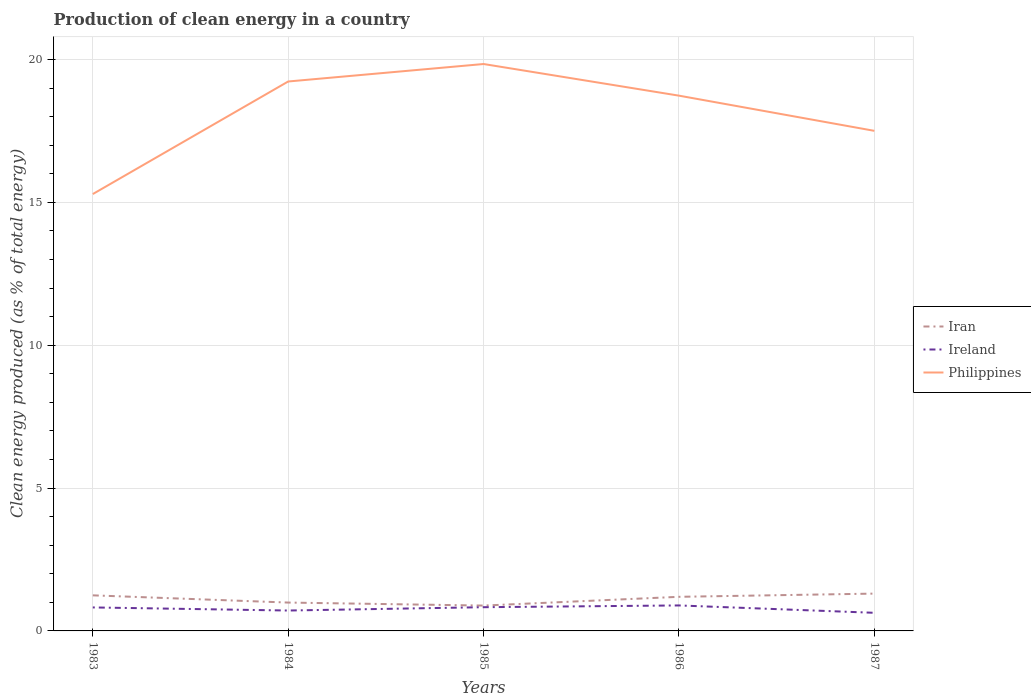Does the line corresponding to Philippines intersect with the line corresponding to Ireland?
Your response must be concise. No. Is the number of lines equal to the number of legend labels?
Provide a short and direct response. Yes. Across all years, what is the maximum percentage of clean energy produced in Ireland?
Provide a succinct answer. 0.63. What is the total percentage of clean energy produced in Philippines in the graph?
Provide a short and direct response. 1.11. What is the difference between the highest and the second highest percentage of clean energy produced in Iran?
Your answer should be very brief. 0.42. What is the difference between the highest and the lowest percentage of clean energy produced in Philippines?
Offer a very short reply. 3. Are the values on the major ticks of Y-axis written in scientific E-notation?
Ensure brevity in your answer.  No. Does the graph contain any zero values?
Your response must be concise. No. How are the legend labels stacked?
Make the answer very short. Vertical. What is the title of the graph?
Offer a very short reply. Production of clean energy in a country. Does "Congo (Democratic)" appear as one of the legend labels in the graph?
Offer a very short reply. No. What is the label or title of the Y-axis?
Ensure brevity in your answer.  Clean energy produced (as % of total energy). What is the Clean energy produced (as % of total energy) in Iran in 1983?
Offer a very short reply. 1.25. What is the Clean energy produced (as % of total energy) of Ireland in 1983?
Give a very brief answer. 0.82. What is the Clean energy produced (as % of total energy) of Philippines in 1983?
Offer a terse response. 15.29. What is the Clean energy produced (as % of total energy) in Iran in 1984?
Your answer should be compact. 0.99. What is the Clean energy produced (as % of total energy) in Ireland in 1984?
Offer a very short reply. 0.71. What is the Clean energy produced (as % of total energy) of Philippines in 1984?
Give a very brief answer. 19.23. What is the Clean energy produced (as % of total energy) in Iran in 1985?
Your answer should be compact. 0.89. What is the Clean energy produced (as % of total energy) of Ireland in 1985?
Offer a very short reply. 0.83. What is the Clean energy produced (as % of total energy) in Philippines in 1985?
Your answer should be very brief. 19.84. What is the Clean energy produced (as % of total energy) in Iran in 1986?
Keep it short and to the point. 1.19. What is the Clean energy produced (as % of total energy) in Ireland in 1986?
Offer a very short reply. 0.89. What is the Clean energy produced (as % of total energy) of Philippines in 1986?
Your response must be concise. 18.73. What is the Clean energy produced (as % of total energy) in Iran in 1987?
Give a very brief answer. 1.31. What is the Clean energy produced (as % of total energy) in Ireland in 1987?
Offer a terse response. 0.63. What is the Clean energy produced (as % of total energy) of Philippines in 1987?
Your response must be concise. 17.5. Across all years, what is the maximum Clean energy produced (as % of total energy) of Iran?
Give a very brief answer. 1.31. Across all years, what is the maximum Clean energy produced (as % of total energy) of Ireland?
Offer a very short reply. 0.89. Across all years, what is the maximum Clean energy produced (as % of total energy) in Philippines?
Keep it short and to the point. 19.84. Across all years, what is the minimum Clean energy produced (as % of total energy) in Iran?
Offer a terse response. 0.89. Across all years, what is the minimum Clean energy produced (as % of total energy) in Ireland?
Make the answer very short. 0.63. Across all years, what is the minimum Clean energy produced (as % of total energy) of Philippines?
Make the answer very short. 15.29. What is the total Clean energy produced (as % of total energy) of Iran in the graph?
Make the answer very short. 5.63. What is the total Clean energy produced (as % of total energy) in Ireland in the graph?
Give a very brief answer. 3.89. What is the total Clean energy produced (as % of total energy) in Philippines in the graph?
Your answer should be compact. 90.6. What is the difference between the Clean energy produced (as % of total energy) in Iran in 1983 and that in 1984?
Make the answer very short. 0.25. What is the difference between the Clean energy produced (as % of total energy) in Ireland in 1983 and that in 1984?
Give a very brief answer. 0.11. What is the difference between the Clean energy produced (as % of total energy) in Philippines in 1983 and that in 1984?
Make the answer very short. -3.94. What is the difference between the Clean energy produced (as % of total energy) in Iran in 1983 and that in 1985?
Offer a very short reply. 0.36. What is the difference between the Clean energy produced (as % of total energy) of Ireland in 1983 and that in 1985?
Provide a short and direct response. -0.01. What is the difference between the Clean energy produced (as % of total energy) of Philippines in 1983 and that in 1985?
Offer a very short reply. -4.55. What is the difference between the Clean energy produced (as % of total energy) in Iran in 1983 and that in 1986?
Your answer should be compact. 0.05. What is the difference between the Clean energy produced (as % of total energy) in Ireland in 1983 and that in 1986?
Provide a succinct answer. -0.07. What is the difference between the Clean energy produced (as % of total energy) in Philippines in 1983 and that in 1986?
Offer a very short reply. -3.44. What is the difference between the Clean energy produced (as % of total energy) in Iran in 1983 and that in 1987?
Keep it short and to the point. -0.06. What is the difference between the Clean energy produced (as % of total energy) in Ireland in 1983 and that in 1987?
Offer a terse response. 0.19. What is the difference between the Clean energy produced (as % of total energy) of Philippines in 1983 and that in 1987?
Provide a short and direct response. -2.21. What is the difference between the Clean energy produced (as % of total energy) in Iran in 1984 and that in 1985?
Offer a terse response. 0.11. What is the difference between the Clean energy produced (as % of total energy) in Ireland in 1984 and that in 1985?
Keep it short and to the point. -0.12. What is the difference between the Clean energy produced (as % of total energy) of Philippines in 1984 and that in 1985?
Make the answer very short. -0.61. What is the difference between the Clean energy produced (as % of total energy) in Iran in 1984 and that in 1986?
Your response must be concise. -0.2. What is the difference between the Clean energy produced (as % of total energy) in Ireland in 1984 and that in 1986?
Provide a succinct answer. -0.18. What is the difference between the Clean energy produced (as % of total energy) of Philippines in 1984 and that in 1986?
Offer a very short reply. 0.5. What is the difference between the Clean energy produced (as % of total energy) of Iran in 1984 and that in 1987?
Give a very brief answer. -0.31. What is the difference between the Clean energy produced (as % of total energy) of Ireland in 1984 and that in 1987?
Ensure brevity in your answer.  0.08. What is the difference between the Clean energy produced (as % of total energy) of Philippines in 1984 and that in 1987?
Provide a succinct answer. 1.73. What is the difference between the Clean energy produced (as % of total energy) of Iran in 1985 and that in 1986?
Ensure brevity in your answer.  -0.31. What is the difference between the Clean energy produced (as % of total energy) in Ireland in 1985 and that in 1986?
Your answer should be compact. -0.06. What is the difference between the Clean energy produced (as % of total energy) in Philippines in 1985 and that in 1986?
Offer a very short reply. 1.11. What is the difference between the Clean energy produced (as % of total energy) in Iran in 1985 and that in 1987?
Your response must be concise. -0.42. What is the difference between the Clean energy produced (as % of total energy) in Ireland in 1985 and that in 1987?
Keep it short and to the point. 0.2. What is the difference between the Clean energy produced (as % of total energy) of Philippines in 1985 and that in 1987?
Provide a short and direct response. 2.34. What is the difference between the Clean energy produced (as % of total energy) of Iran in 1986 and that in 1987?
Your answer should be very brief. -0.11. What is the difference between the Clean energy produced (as % of total energy) in Ireland in 1986 and that in 1987?
Your response must be concise. 0.26. What is the difference between the Clean energy produced (as % of total energy) of Philippines in 1986 and that in 1987?
Ensure brevity in your answer.  1.23. What is the difference between the Clean energy produced (as % of total energy) of Iran in 1983 and the Clean energy produced (as % of total energy) of Ireland in 1984?
Your response must be concise. 0.53. What is the difference between the Clean energy produced (as % of total energy) in Iran in 1983 and the Clean energy produced (as % of total energy) in Philippines in 1984?
Your answer should be compact. -17.99. What is the difference between the Clean energy produced (as % of total energy) of Ireland in 1983 and the Clean energy produced (as % of total energy) of Philippines in 1984?
Keep it short and to the point. -18.41. What is the difference between the Clean energy produced (as % of total energy) of Iran in 1983 and the Clean energy produced (as % of total energy) of Ireland in 1985?
Offer a very short reply. 0.42. What is the difference between the Clean energy produced (as % of total energy) in Iran in 1983 and the Clean energy produced (as % of total energy) in Philippines in 1985?
Provide a succinct answer. -18.6. What is the difference between the Clean energy produced (as % of total energy) of Ireland in 1983 and the Clean energy produced (as % of total energy) of Philippines in 1985?
Offer a terse response. -19.02. What is the difference between the Clean energy produced (as % of total energy) of Iran in 1983 and the Clean energy produced (as % of total energy) of Ireland in 1986?
Give a very brief answer. 0.35. What is the difference between the Clean energy produced (as % of total energy) in Iran in 1983 and the Clean energy produced (as % of total energy) in Philippines in 1986?
Keep it short and to the point. -17.49. What is the difference between the Clean energy produced (as % of total energy) of Ireland in 1983 and the Clean energy produced (as % of total energy) of Philippines in 1986?
Offer a very short reply. -17.91. What is the difference between the Clean energy produced (as % of total energy) of Iran in 1983 and the Clean energy produced (as % of total energy) of Ireland in 1987?
Offer a terse response. 0.61. What is the difference between the Clean energy produced (as % of total energy) in Iran in 1983 and the Clean energy produced (as % of total energy) in Philippines in 1987?
Ensure brevity in your answer.  -16.26. What is the difference between the Clean energy produced (as % of total energy) in Ireland in 1983 and the Clean energy produced (as % of total energy) in Philippines in 1987?
Give a very brief answer. -16.68. What is the difference between the Clean energy produced (as % of total energy) of Iran in 1984 and the Clean energy produced (as % of total energy) of Ireland in 1985?
Offer a terse response. 0.16. What is the difference between the Clean energy produced (as % of total energy) in Iran in 1984 and the Clean energy produced (as % of total energy) in Philippines in 1985?
Give a very brief answer. -18.85. What is the difference between the Clean energy produced (as % of total energy) in Ireland in 1984 and the Clean energy produced (as % of total energy) in Philippines in 1985?
Ensure brevity in your answer.  -19.13. What is the difference between the Clean energy produced (as % of total energy) of Iran in 1984 and the Clean energy produced (as % of total energy) of Ireland in 1986?
Offer a very short reply. 0.1. What is the difference between the Clean energy produced (as % of total energy) of Iran in 1984 and the Clean energy produced (as % of total energy) of Philippines in 1986?
Your response must be concise. -17.74. What is the difference between the Clean energy produced (as % of total energy) of Ireland in 1984 and the Clean energy produced (as % of total energy) of Philippines in 1986?
Provide a succinct answer. -18.02. What is the difference between the Clean energy produced (as % of total energy) of Iran in 1984 and the Clean energy produced (as % of total energy) of Ireland in 1987?
Give a very brief answer. 0.36. What is the difference between the Clean energy produced (as % of total energy) in Iran in 1984 and the Clean energy produced (as % of total energy) in Philippines in 1987?
Offer a terse response. -16.51. What is the difference between the Clean energy produced (as % of total energy) in Ireland in 1984 and the Clean energy produced (as % of total energy) in Philippines in 1987?
Give a very brief answer. -16.79. What is the difference between the Clean energy produced (as % of total energy) of Iran in 1985 and the Clean energy produced (as % of total energy) of Ireland in 1986?
Keep it short and to the point. -0. What is the difference between the Clean energy produced (as % of total energy) in Iran in 1985 and the Clean energy produced (as % of total energy) in Philippines in 1986?
Give a very brief answer. -17.85. What is the difference between the Clean energy produced (as % of total energy) of Ireland in 1985 and the Clean energy produced (as % of total energy) of Philippines in 1986?
Keep it short and to the point. -17.9. What is the difference between the Clean energy produced (as % of total energy) in Iran in 1985 and the Clean energy produced (as % of total energy) in Ireland in 1987?
Your answer should be very brief. 0.25. What is the difference between the Clean energy produced (as % of total energy) of Iran in 1985 and the Clean energy produced (as % of total energy) of Philippines in 1987?
Provide a succinct answer. -16.62. What is the difference between the Clean energy produced (as % of total energy) of Ireland in 1985 and the Clean energy produced (as % of total energy) of Philippines in 1987?
Keep it short and to the point. -16.67. What is the difference between the Clean energy produced (as % of total energy) of Iran in 1986 and the Clean energy produced (as % of total energy) of Ireland in 1987?
Offer a terse response. 0.56. What is the difference between the Clean energy produced (as % of total energy) of Iran in 1986 and the Clean energy produced (as % of total energy) of Philippines in 1987?
Your answer should be compact. -16.31. What is the difference between the Clean energy produced (as % of total energy) in Ireland in 1986 and the Clean energy produced (as % of total energy) in Philippines in 1987?
Offer a very short reply. -16.61. What is the average Clean energy produced (as % of total energy) of Iran per year?
Your answer should be very brief. 1.13. What is the average Clean energy produced (as % of total energy) of Ireland per year?
Ensure brevity in your answer.  0.78. What is the average Clean energy produced (as % of total energy) in Philippines per year?
Your answer should be compact. 18.12. In the year 1983, what is the difference between the Clean energy produced (as % of total energy) of Iran and Clean energy produced (as % of total energy) of Ireland?
Ensure brevity in your answer.  0.42. In the year 1983, what is the difference between the Clean energy produced (as % of total energy) of Iran and Clean energy produced (as % of total energy) of Philippines?
Provide a short and direct response. -14.05. In the year 1983, what is the difference between the Clean energy produced (as % of total energy) in Ireland and Clean energy produced (as % of total energy) in Philippines?
Offer a terse response. -14.47. In the year 1984, what is the difference between the Clean energy produced (as % of total energy) in Iran and Clean energy produced (as % of total energy) in Ireland?
Provide a short and direct response. 0.28. In the year 1984, what is the difference between the Clean energy produced (as % of total energy) of Iran and Clean energy produced (as % of total energy) of Philippines?
Ensure brevity in your answer.  -18.24. In the year 1984, what is the difference between the Clean energy produced (as % of total energy) of Ireland and Clean energy produced (as % of total energy) of Philippines?
Make the answer very short. -18.52. In the year 1985, what is the difference between the Clean energy produced (as % of total energy) in Iran and Clean energy produced (as % of total energy) in Ireland?
Make the answer very short. 0.06. In the year 1985, what is the difference between the Clean energy produced (as % of total energy) in Iran and Clean energy produced (as % of total energy) in Philippines?
Ensure brevity in your answer.  -18.96. In the year 1985, what is the difference between the Clean energy produced (as % of total energy) in Ireland and Clean energy produced (as % of total energy) in Philippines?
Offer a very short reply. -19.01. In the year 1986, what is the difference between the Clean energy produced (as % of total energy) in Iran and Clean energy produced (as % of total energy) in Ireland?
Offer a terse response. 0.3. In the year 1986, what is the difference between the Clean energy produced (as % of total energy) of Iran and Clean energy produced (as % of total energy) of Philippines?
Offer a very short reply. -17.54. In the year 1986, what is the difference between the Clean energy produced (as % of total energy) in Ireland and Clean energy produced (as % of total energy) in Philippines?
Offer a terse response. -17.84. In the year 1987, what is the difference between the Clean energy produced (as % of total energy) of Iran and Clean energy produced (as % of total energy) of Ireland?
Give a very brief answer. 0.67. In the year 1987, what is the difference between the Clean energy produced (as % of total energy) of Iran and Clean energy produced (as % of total energy) of Philippines?
Your answer should be compact. -16.2. In the year 1987, what is the difference between the Clean energy produced (as % of total energy) in Ireland and Clean energy produced (as % of total energy) in Philippines?
Your response must be concise. -16.87. What is the ratio of the Clean energy produced (as % of total energy) in Iran in 1983 to that in 1984?
Give a very brief answer. 1.25. What is the ratio of the Clean energy produced (as % of total energy) of Ireland in 1983 to that in 1984?
Make the answer very short. 1.15. What is the ratio of the Clean energy produced (as % of total energy) in Philippines in 1983 to that in 1984?
Ensure brevity in your answer.  0.8. What is the ratio of the Clean energy produced (as % of total energy) in Iran in 1983 to that in 1985?
Ensure brevity in your answer.  1.4. What is the ratio of the Clean energy produced (as % of total energy) of Ireland in 1983 to that in 1985?
Give a very brief answer. 0.99. What is the ratio of the Clean energy produced (as % of total energy) of Philippines in 1983 to that in 1985?
Provide a short and direct response. 0.77. What is the ratio of the Clean energy produced (as % of total energy) in Iran in 1983 to that in 1986?
Your response must be concise. 1.04. What is the ratio of the Clean energy produced (as % of total energy) in Ireland in 1983 to that in 1986?
Ensure brevity in your answer.  0.92. What is the ratio of the Clean energy produced (as % of total energy) in Philippines in 1983 to that in 1986?
Offer a very short reply. 0.82. What is the ratio of the Clean energy produced (as % of total energy) in Iran in 1983 to that in 1987?
Keep it short and to the point. 0.95. What is the ratio of the Clean energy produced (as % of total energy) of Ireland in 1983 to that in 1987?
Your response must be concise. 1.3. What is the ratio of the Clean energy produced (as % of total energy) of Philippines in 1983 to that in 1987?
Your response must be concise. 0.87. What is the ratio of the Clean energy produced (as % of total energy) in Iran in 1984 to that in 1985?
Provide a short and direct response. 1.12. What is the ratio of the Clean energy produced (as % of total energy) in Ireland in 1984 to that in 1985?
Your response must be concise. 0.86. What is the ratio of the Clean energy produced (as % of total energy) of Philippines in 1984 to that in 1985?
Ensure brevity in your answer.  0.97. What is the ratio of the Clean energy produced (as % of total energy) in Iran in 1984 to that in 1986?
Make the answer very short. 0.83. What is the ratio of the Clean energy produced (as % of total energy) in Ireland in 1984 to that in 1986?
Your answer should be compact. 0.8. What is the ratio of the Clean energy produced (as % of total energy) of Philippines in 1984 to that in 1986?
Keep it short and to the point. 1.03. What is the ratio of the Clean energy produced (as % of total energy) of Iran in 1984 to that in 1987?
Ensure brevity in your answer.  0.76. What is the ratio of the Clean energy produced (as % of total energy) of Ireland in 1984 to that in 1987?
Make the answer very short. 1.13. What is the ratio of the Clean energy produced (as % of total energy) of Philippines in 1984 to that in 1987?
Make the answer very short. 1.1. What is the ratio of the Clean energy produced (as % of total energy) in Iran in 1985 to that in 1986?
Offer a terse response. 0.74. What is the ratio of the Clean energy produced (as % of total energy) of Philippines in 1985 to that in 1986?
Your answer should be very brief. 1.06. What is the ratio of the Clean energy produced (as % of total energy) of Iran in 1985 to that in 1987?
Provide a succinct answer. 0.68. What is the ratio of the Clean energy produced (as % of total energy) in Ireland in 1985 to that in 1987?
Your answer should be compact. 1.31. What is the ratio of the Clean energy produced (as % of total energy) of Philippines in 1985 to that in 1987?
Offer a terse response. 1.13. What is the ratio of the Clean energy produced (as % of total energy) in Iran in 1986 to that in 1987?
Your answer should be very brief. 0.91. What is the ratio of the Clean energy produced (as % of total energy) of Ireland in 1986 to that in 1987?
Provide a short and direct response. 1.41. What is the ratio of the Clean energy produced (as % of total energy) in Philippines in 1986 to that in 1987?
Ensure brevity in your answer.  1.07. What is the difference between the highest and the second highest Clean energy produced (as % of total energy) of Iran?
Your answer should be very brief. 0.06. What is the difference between the highest and the second highest Clean energy produced (as % of total energy) in Ireland?
Offer a very short reply. 0.06. What is the difference between the highest and the second highest Clean energy produced (as % of total energy) in Philippines?
Your answer should be very brief. 0.61. What is the difference between the highest and the lowest Clean energy produced (as % of total energy) of Iran?
Your response must be concise. 0.42. What is the difference between the highest and the lowest Clean energy produced (as % of total energy) in Ireland?
Offer a very short reply. 0.26. What is the difference between the highest and the lowest Clean energy produced (as % of total energy) of Philippines?
Provide a succinct answer. 4.55. 